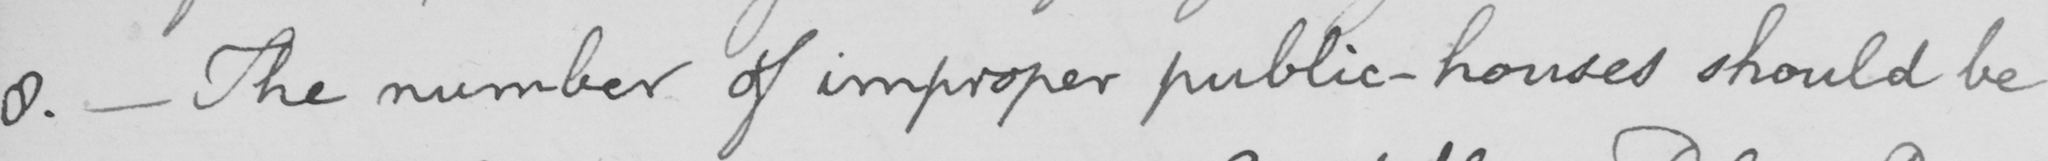Can you tell me what this handwritten text says? 8 .  _  The number of improper public-houses should be 